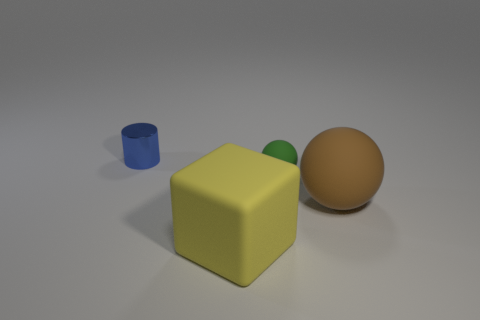Add 2 large yellow objects. How many objects exist? 6 Subtract all blocks. How many objects are left? 3 Add 2 tiny yellow matte balls. How many tiny yellow matte balls exist? 2 Subtract 0 yellow cylinders. How many objects are left? 4 Subtract all big brown matte objects. Subtract all small blue metal cylinders. How many objects are left? 2 Add 3 matte balls. How many matte balls are left? 5 